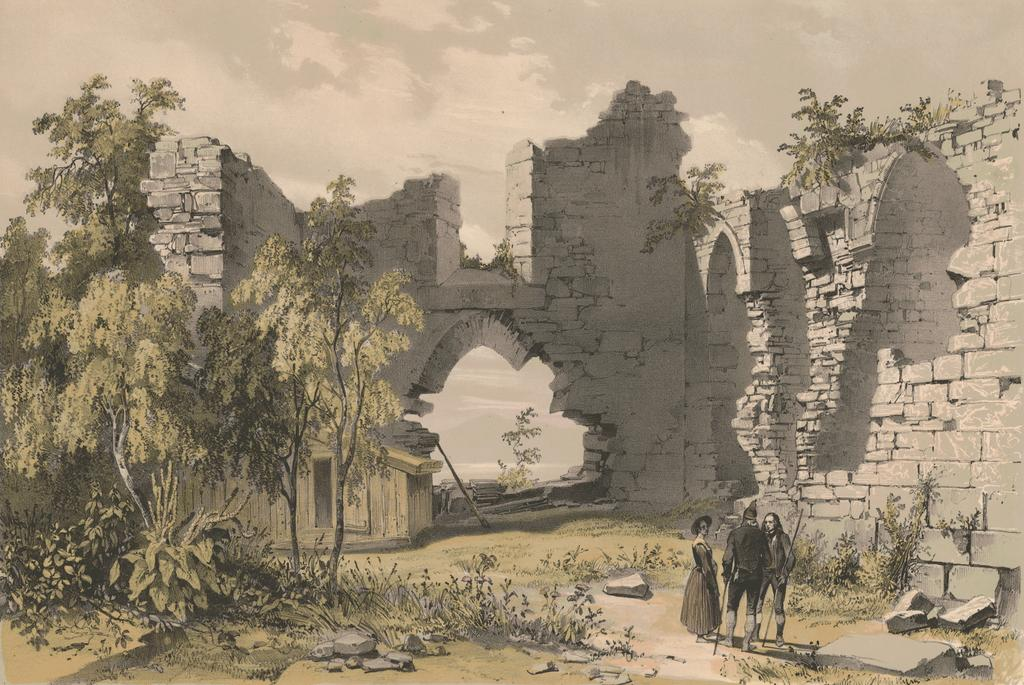What is depicted in the painting in the image? There is a painting of a monument in the image. What else can be seen in the image besides the painting? There are people standing on the ground, stones, plants, and trees visible in the image. How would you describe the sky in the image? The sky is visible in the image and appears cloudy. How many horses are present in the image? There are no horses visible in the image. What type of furniture can be seen in the image? There is no furniture present in the image. 